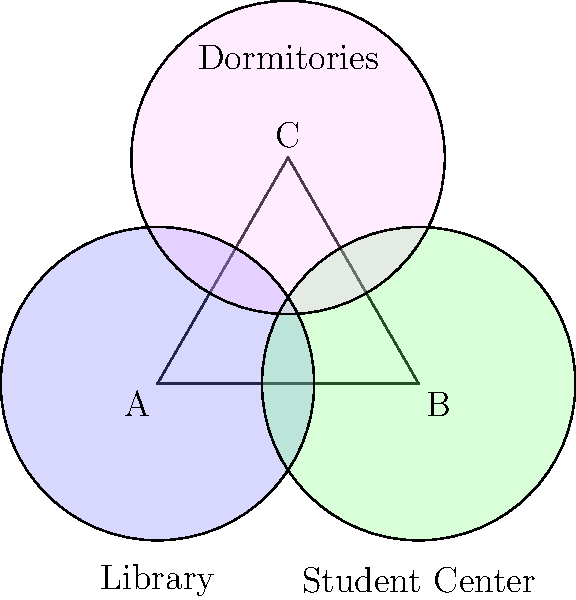The Venn diagram above represents the coverage areas of surveillance cameras at three key locations on campus: the Library (A), Student Center (B), and Dormitories (C). How many distinct regions are created by the overlapping coverage areas? To determine the number of distinct regions created by the overlapping coverage areas, let's follow these steps:

1. Identify the possible combinations of overlapping areas:
   - A only
   - B only
   - C only
   - A and B
   - A and C
   - B and C
   - A, B, and C
   - Area outside all circles

2. Count the regions in the Venn diagram:
   - 3 regions where only one circle covers (A only, B only, C only)
   - 3 regions where two circles overlap (A and B, A and C, B and C)
   - 1 region where all three circles overlap (A, B, and C)
   - 1 region outside all circles

3. Sum up the total number of distinct regions:
   $3 + 3 + 1 + 1 = 8$

Therefore, the Venn diagram shows 8 distinct regions created by the overlapping coverage areas of the surveillance cameras.
Answer: 8 regions 